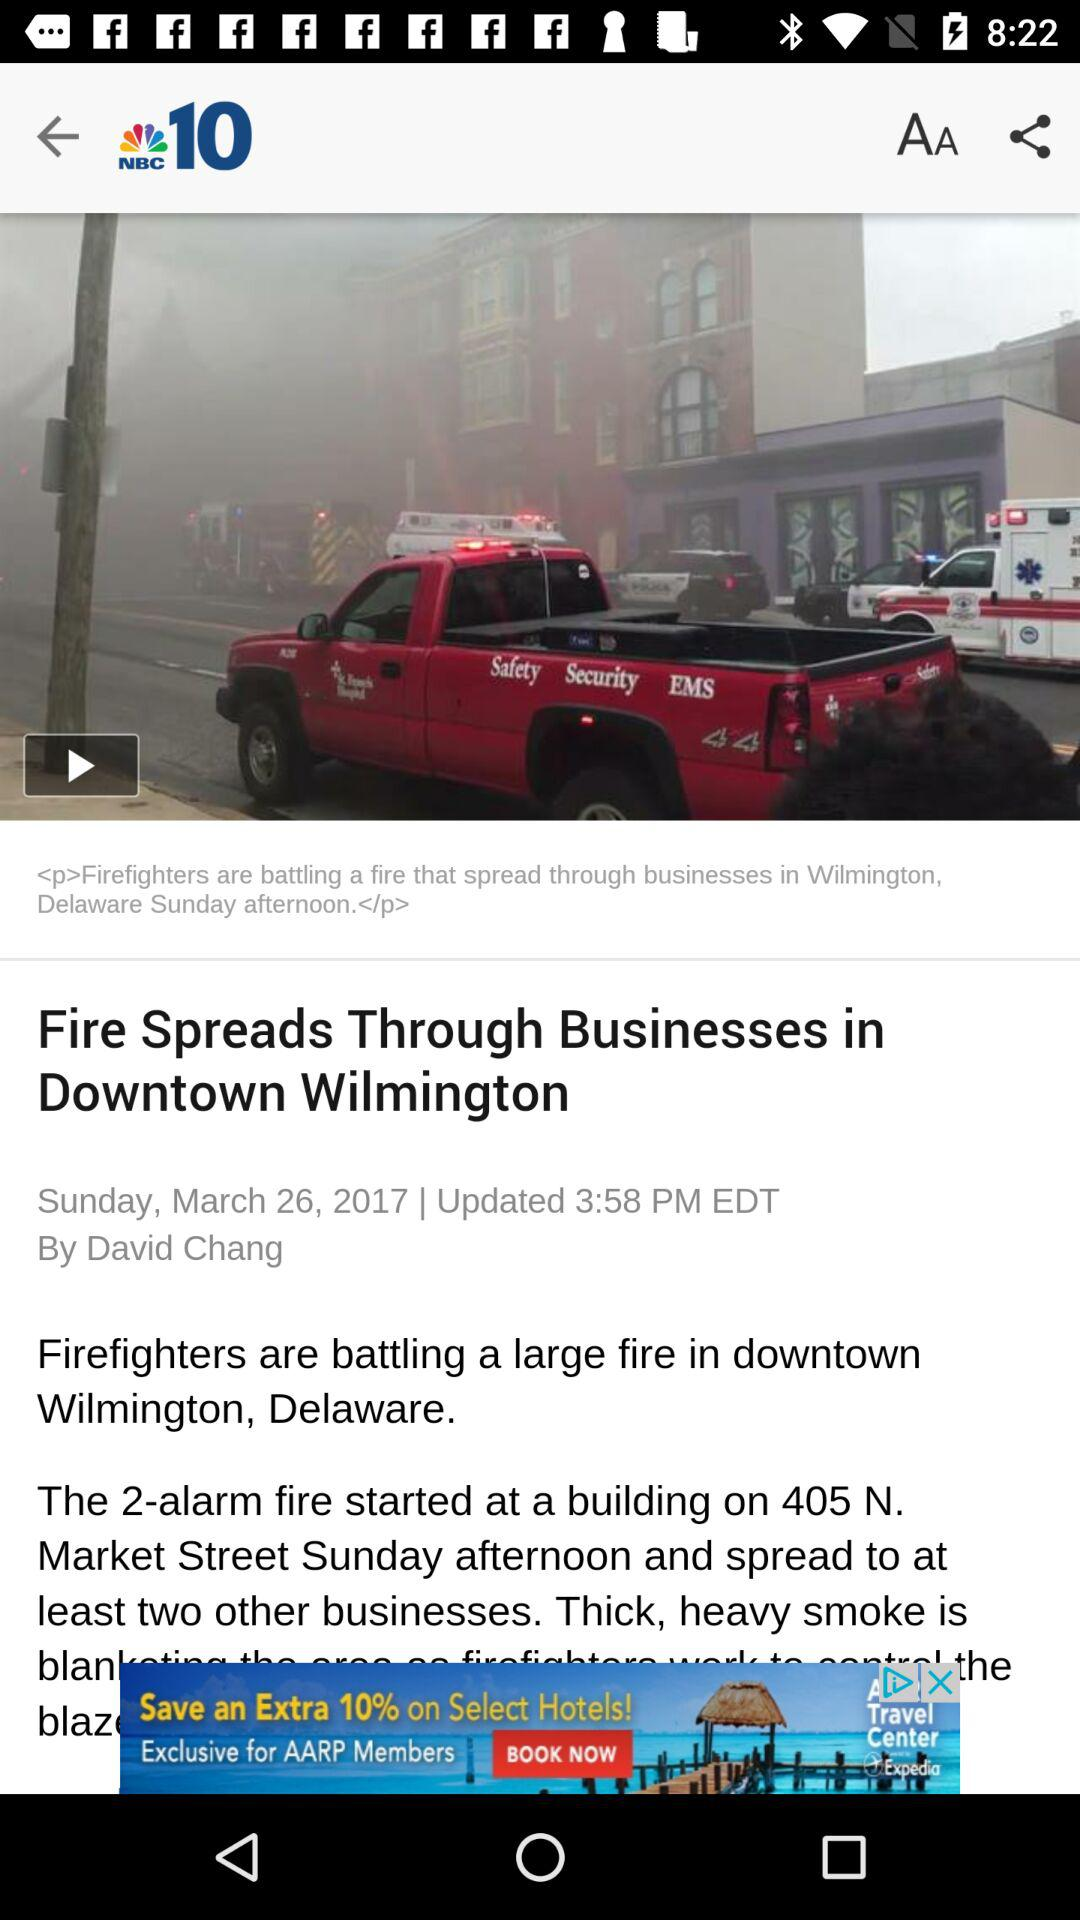Can we share article?
When the provided information is insufficient, respond with <no answer>. <no answer> 